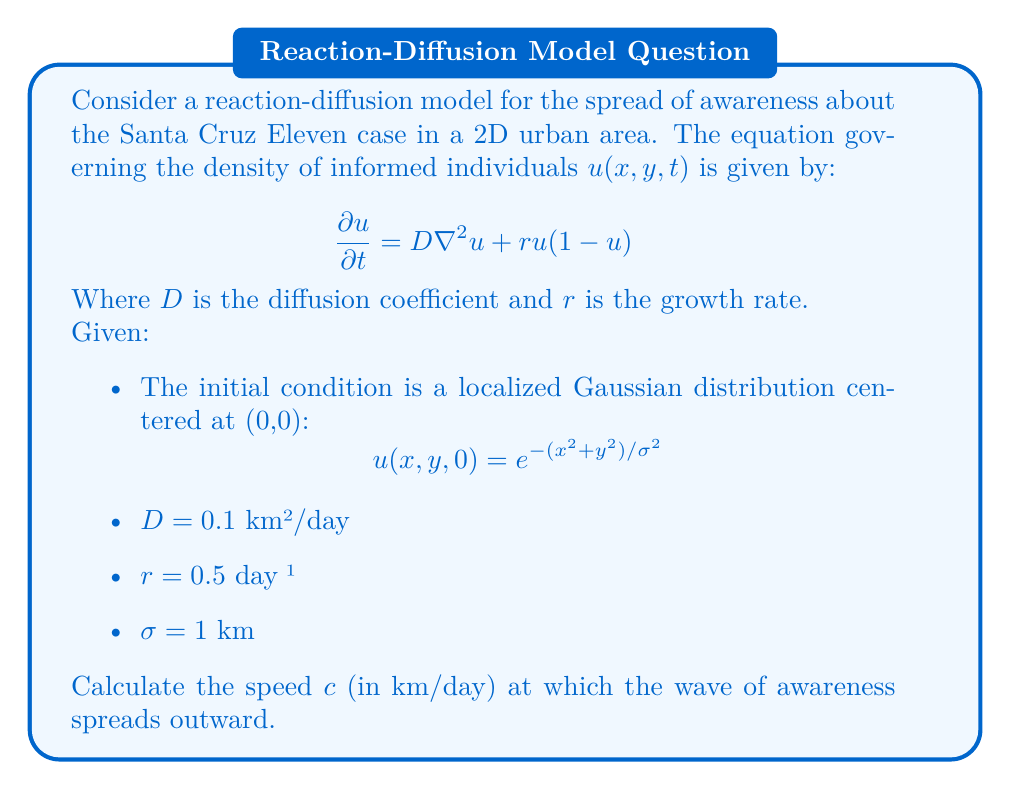Solve this math problem. To solve this problem, we'll use the formula for the wave speed in a reaction-diffusion equation with logistic growth:

1) The general formula for the wave speed in this type of equation is:

   $$c = 2\sqrt{Dr}$$

2) We're given the values:
   $D = 0.1$ km²/day
   $r = 0.5$ day⁻¹

3) Substituting these values into the formula:

   $$c = 2\sqrt{(0.1 \text{ km²/day})(0.5 \text{ day}^{-1})}$$

4) Simplify under the square root:

   $$c = 2\sqrt{0.05 \text{ km²/day²}}$$

5) Calculate the square root:

   $$c = 2(0.2236 \text{ km/day})$$

6) Multiply:

   $$c = 0.4472 \text{ km/day}$$

7) Round to three decimal places:

   $$c \approx 0.447 \text{ km/day}$$

Note: The initial condition and $\sigma$ value don't affect the wave speed in this model, but they determine the initial shape of the informed population distribution.
Answer: 0.447 km/day 